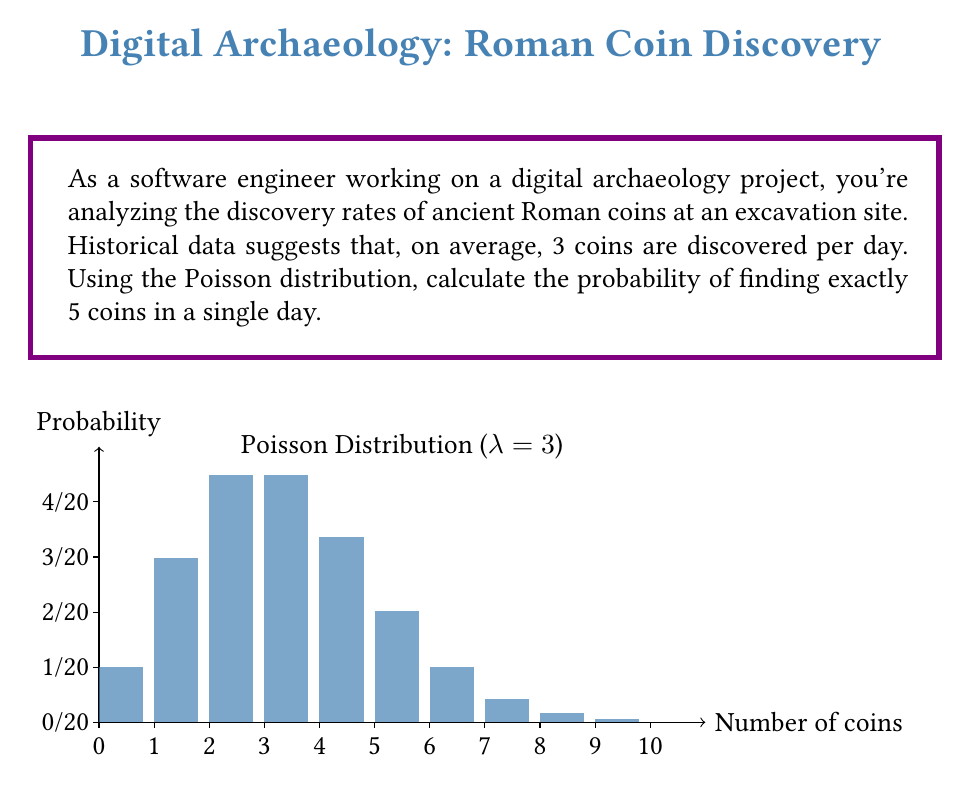Could you help me with this problem? To solve this problem, we'll use the Poisson distribution formula:

$$P(X = k) = \frac{e^{-\lambda} \lambda^k}{k!}$$

Where:
- $\lambda$ is the average rate of occurrence (3 coins per day in this case)
- $k$ is the number of occurrences we're interested in (5 coins in this case)
- $e$ is Euler's number (approximately 2.71828)

Let's substitute the values:

$$P(X = 5) = \frac{e^{-3} 3^5}{5!}$$

Step 1: Calculate $e^{-3}$
$e^{-3} \approx 0.0497871$

Step 2: Calculate $3^5$
$3^5 = 243$

Step 3: Calculate $5!$
$5! = 5 \times 4 \times 3 \times 2 \times 1 = 120$

Step 4: Put it all together
$$P(X = 5) = \frac{0.0497871 \times 243}{120}$$

Step 5: Perform the final calculation
$$P(X = 5) \approx 0.1008$$

Therefore, the probability of finding exactly 5 coins in a single day is approximately 0.1008 or 10.08%.
Answer: $P(X = 5) \approx 0.1008$ or $10.08\%$ 